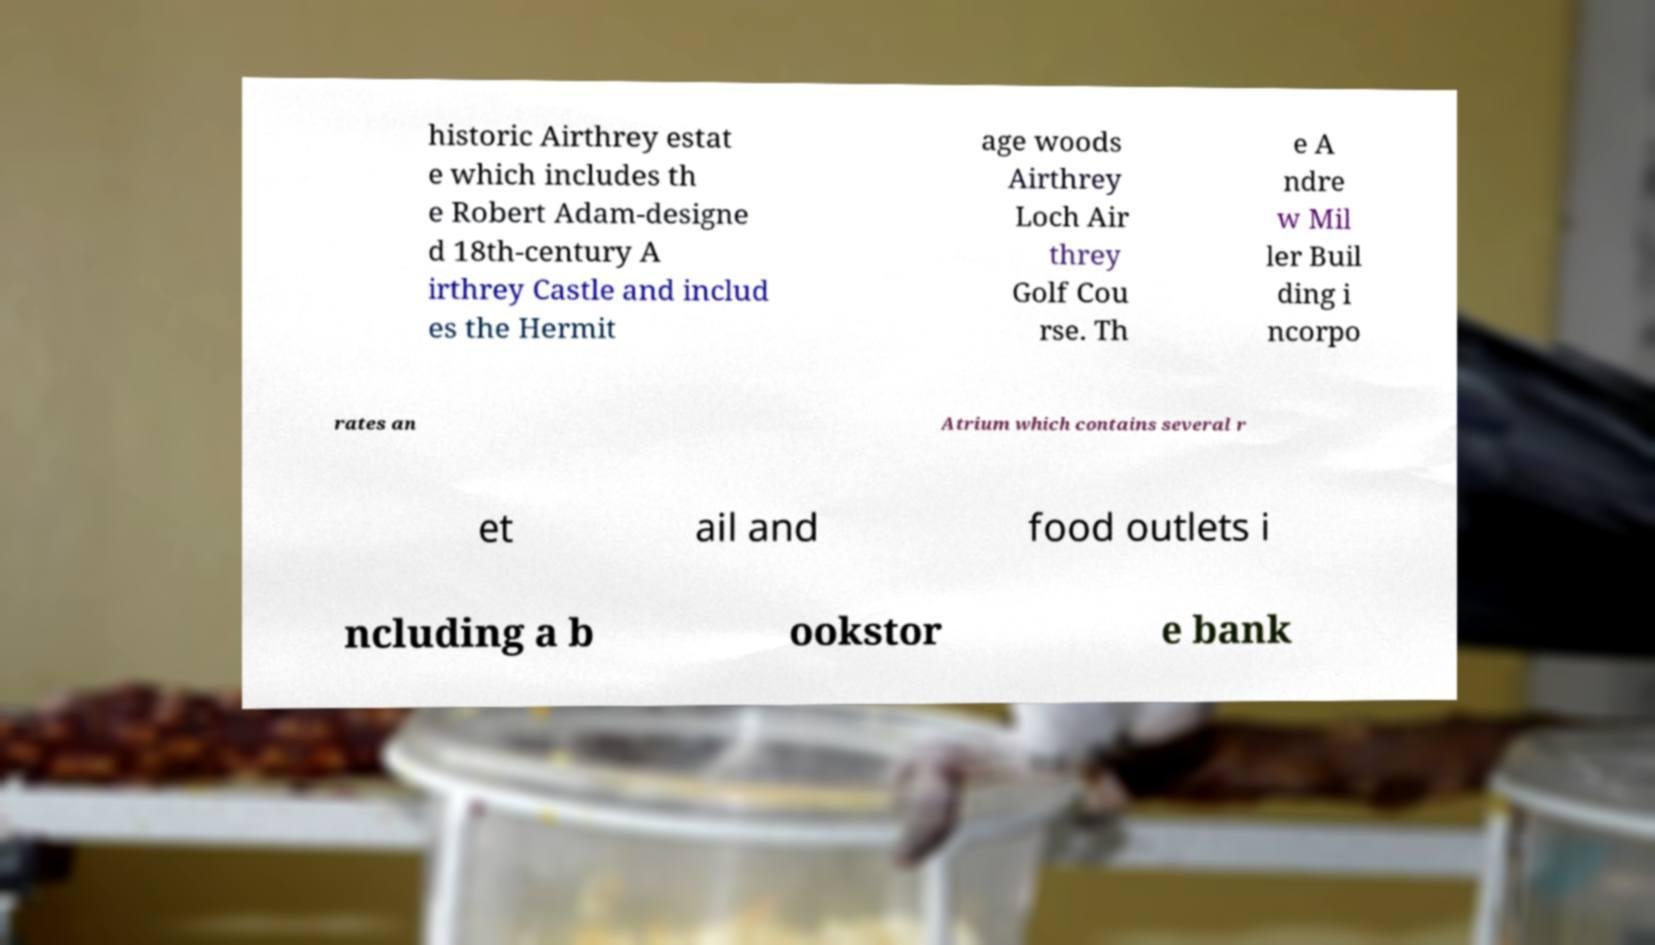What messages or text are displayed in this image? I need them in a readable, typed format. historic Airthrey estat e which includes th e Robert Adam-designe d 18th-century A irthrey Castle and includ es the Hermit age woods Airthrey Loch Air threy Golf Cou rse. Th e A ndre w Mil ler Buil ding i ncorpo rates an Atrium which contains several r et ail and food outlets i ncluding a b ookstor e bank 